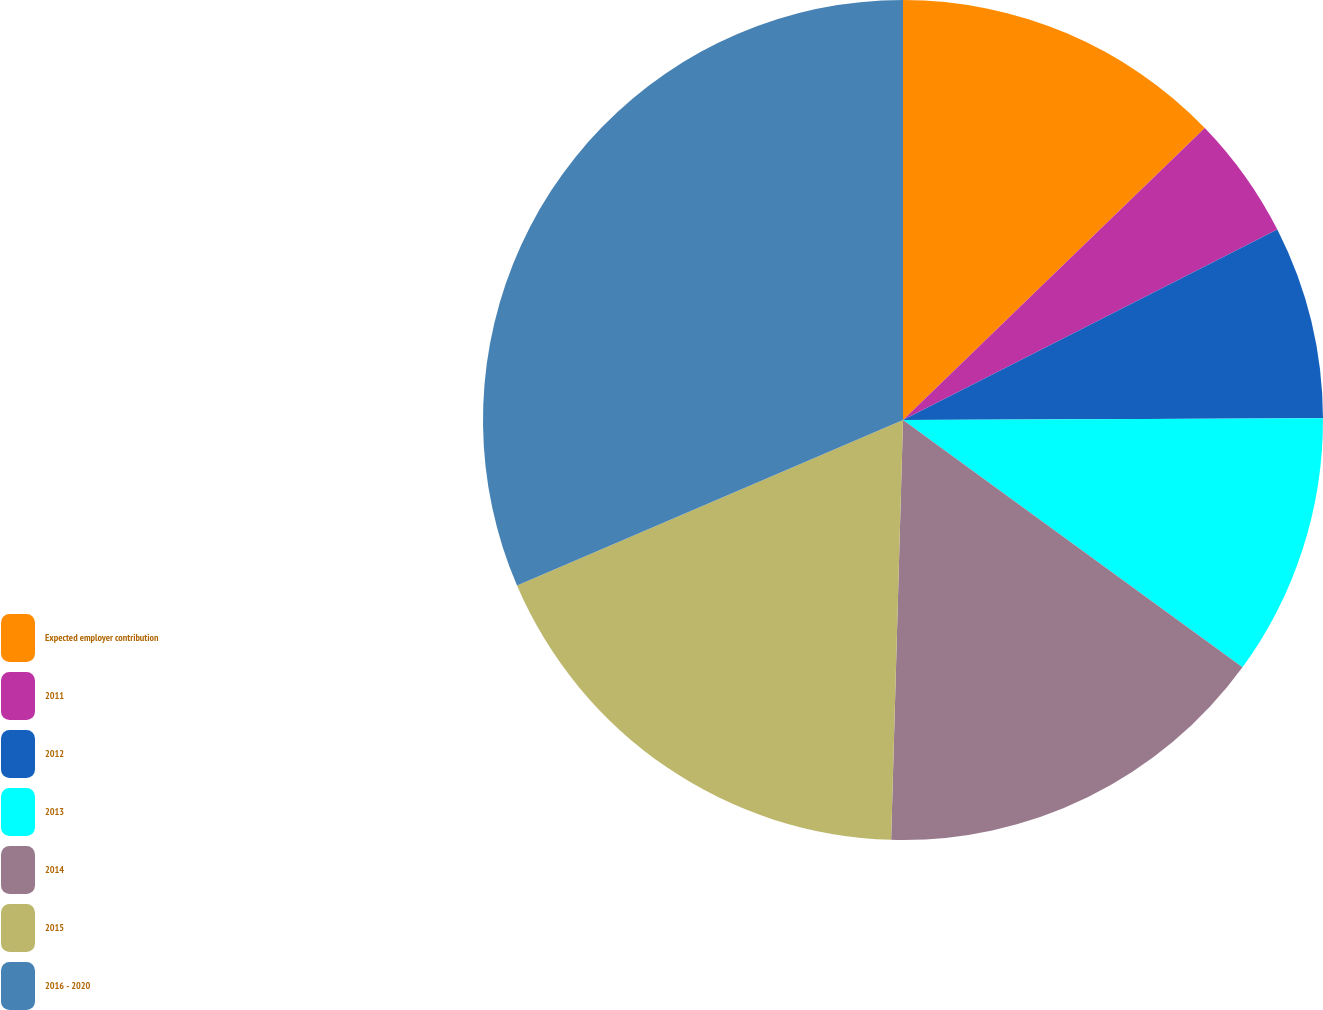Convert chart to OTSL. <chart><loc_0><loc_0><loc_500><loc_500><pie_chart><fcel>Expected employer contribution<fcel>2011<fcel>2012<fcel>2013<fcel>2014<fcel>2015<fcel>2016 - 2020<nl><fcel>12.76%<fcel>4.75%<fcel>7.42%<fcel>10.09%<fcel>15.43%<fcel>18.1%<fcel>31.45%<nl></chart> 